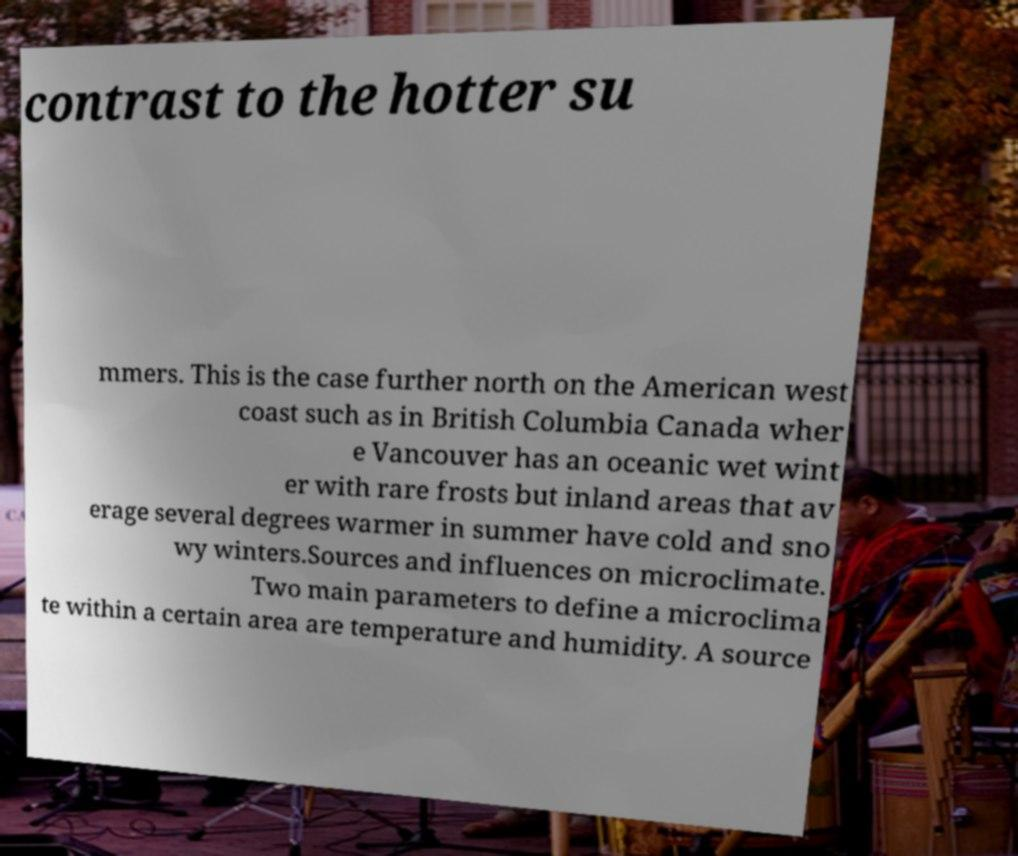Can you accurately transcribe the text from the provided image for me? contrast to the hotter su mmers. This is the case further north on the American west coast such as in British Columbia Canada wher e Vancouver has an oceanic wet wint er with rare frosts but inland areas that av erage several degrees warmer in summer have cold and sno wy winters.Sources and influences on microclimate. Two main parameters to define a microclima te within a certain area are temperature and humidity. A source 